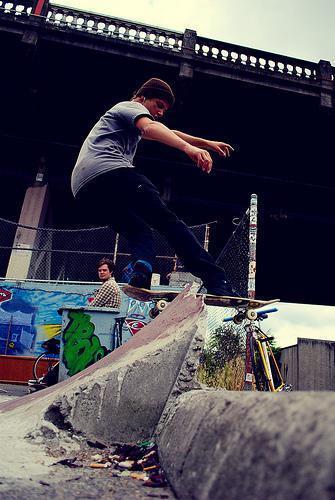How many skaters are there?
Give a very brief answer. 1. 